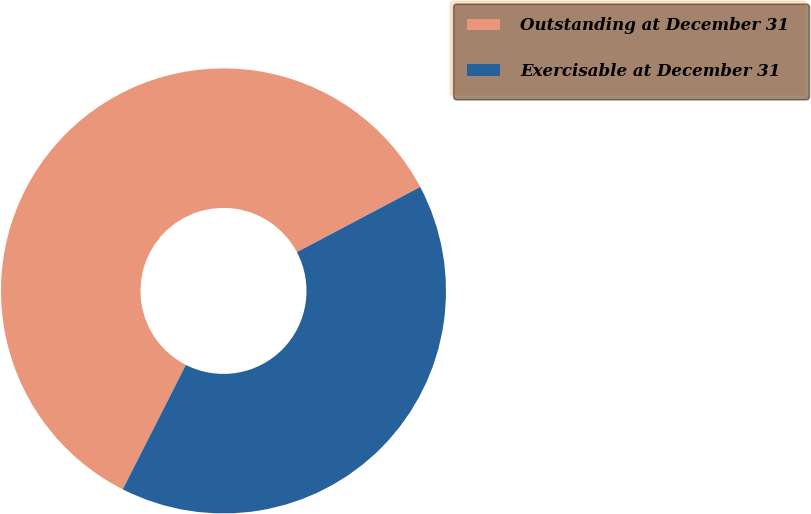<chart> <loc_0><loc_0><loc_500><loc_500><pie_chart><fcel>Outstanding at December 31<fcel>Exercisable at December 31<nl><fcel>59.79%<fcel>40.21%<nl></chart> 